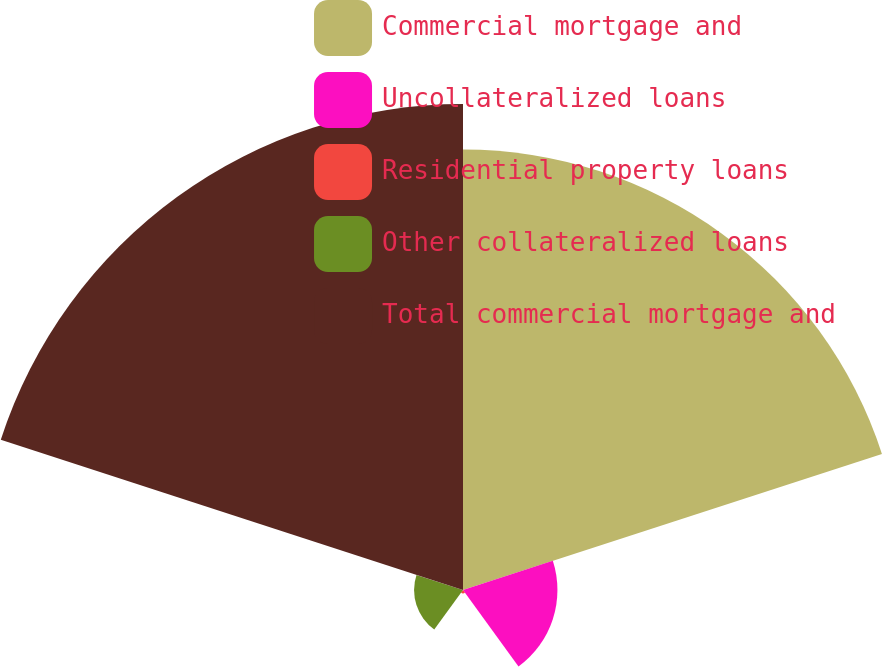<chart> <loc_0><loc_0><loc_500><loc_500><pie_chart><fcel>Commercial mortgage and<fcel>Uncollateralized loans<fcel>Residential property loans<fcel>Other collateralized loans<fcel>Total commercial mortgage and<nl><fcel>41.05%<fcel>8.8%<fcel>0.32%<fcel>4.56%<fcel>45.29%<nl></chart> 